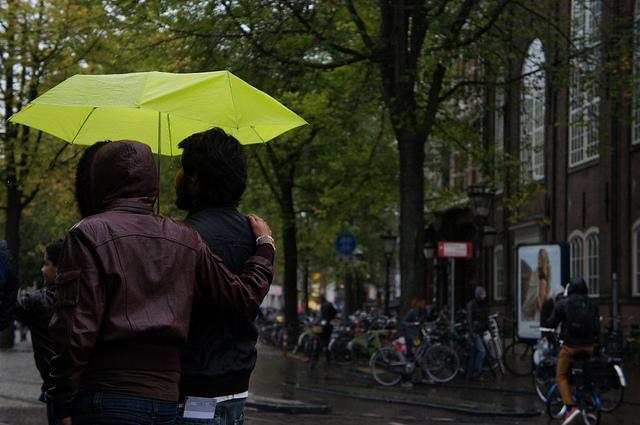How many people are under the umbrella?
Give a very brief answer. 2. How many bicycles are there?
Give a very brief answer. 2. How many people are there?
Give a very brief answer. 4. How many giraffes are shown?
Give a very brief answer. 0. 